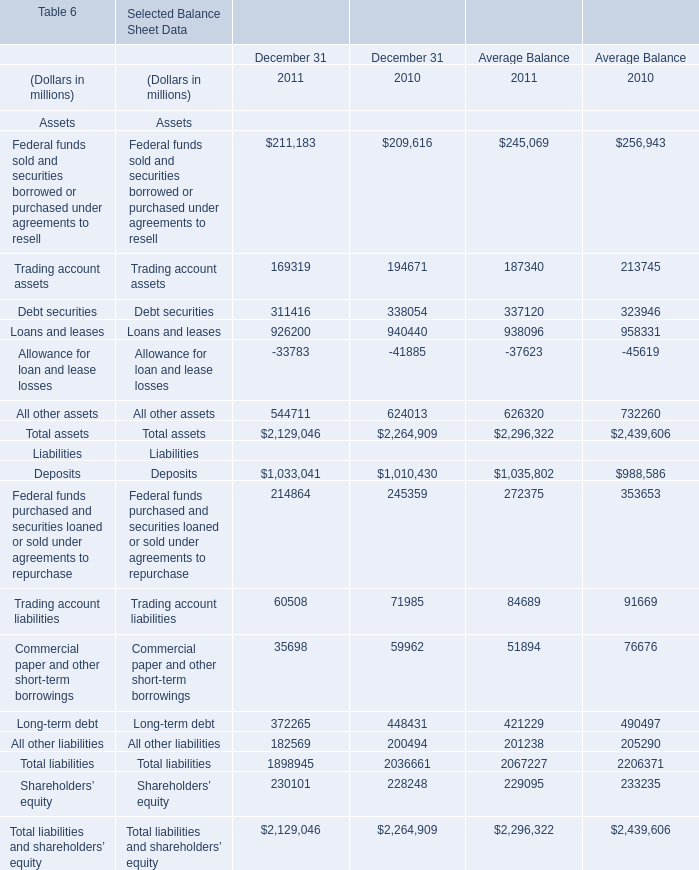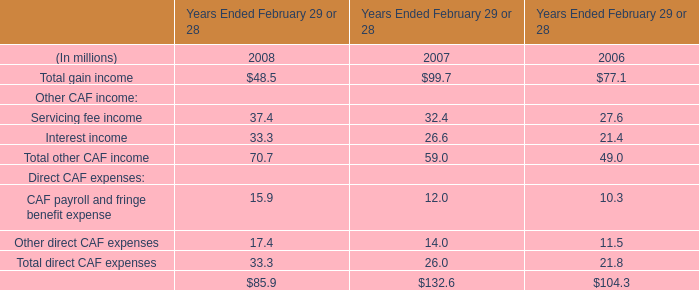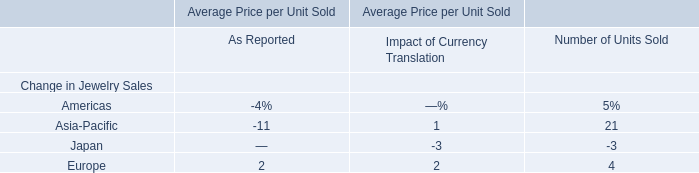What's the total amount of Trading account assets and Debt securities, Loans and leases and Allowance for loan and lease losses in 2011? (in million) 
Computations: (((169319 + 311416) + 926200) - 33783)
Answer: 1373152.0. 